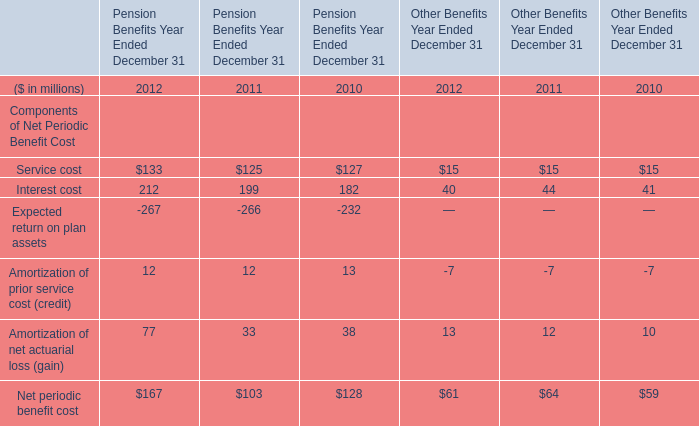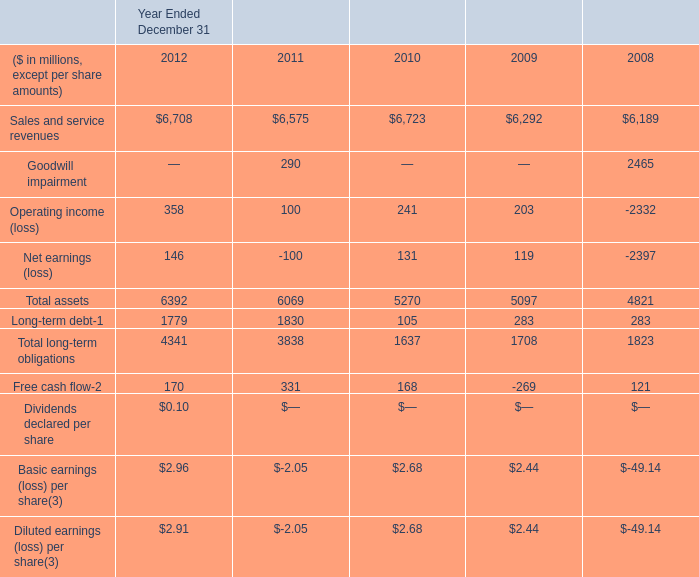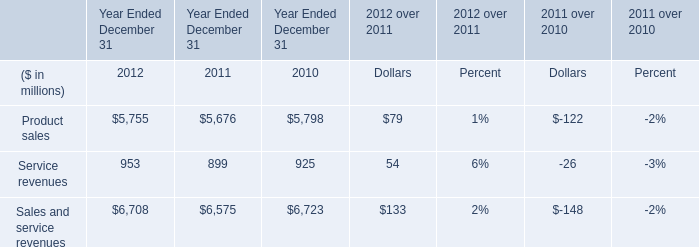In which year is Net periodic benefit cost greater than 120 for Pension Benefits Year Ended December 31? 
Answer: 2010 2012. 